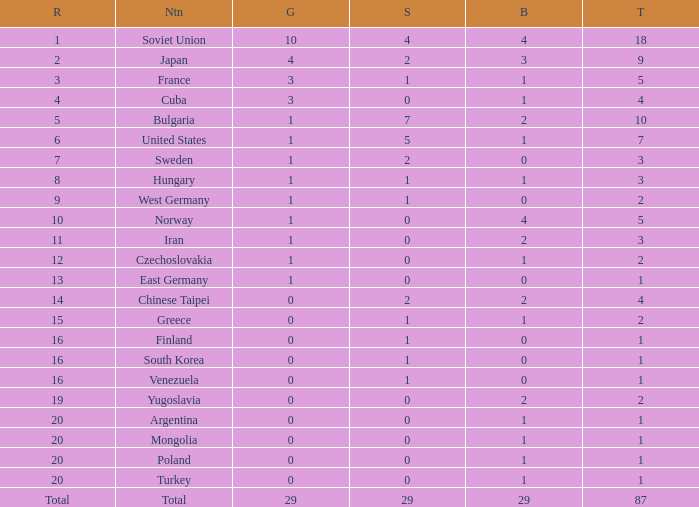What is the average number of bronze medals for total of all nations? 29.0. 